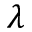Convert formula to latex. <formula><loc_0><loc_0><loc_500><loc_500>\lambda</formula> 